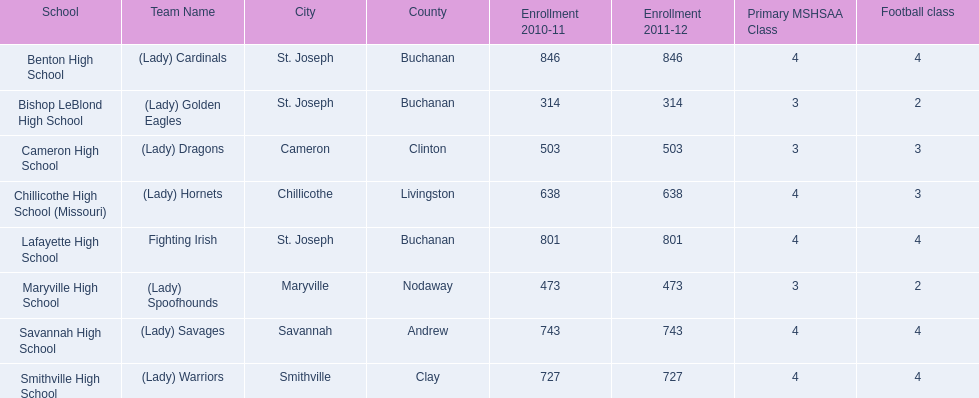What is the lowest number of students enrolled at a school as listed here? 314. What school has 314 students enrolled? Bishop LeBlond High School. 